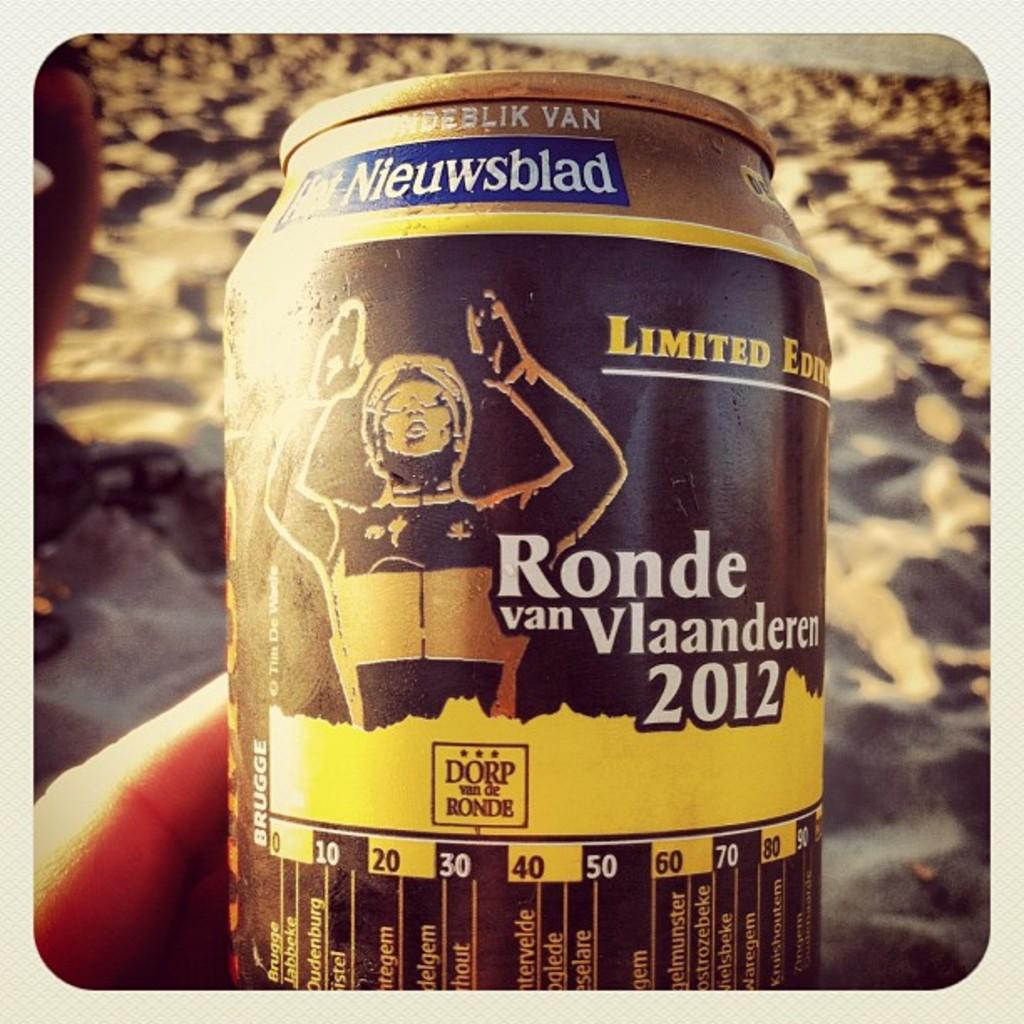<image>
Share a concise interpretation of the image provided. A tin can with the words ronde van vlaanderen on the center of the can. 